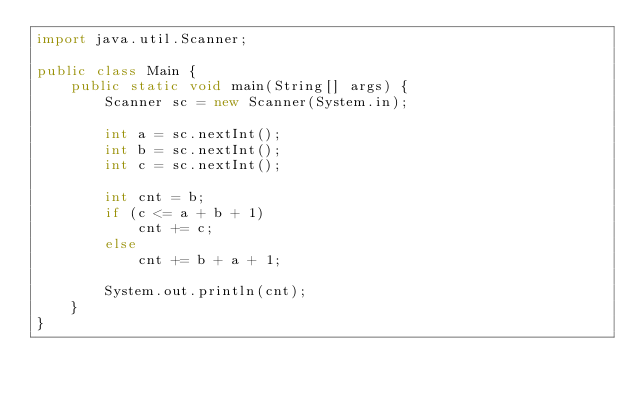Convert code to text. <code><loc_0><loc_0><loc_500><loc_500><_Java_>import java.util.Scanner;

public class Main {
    public static void main(String[] args) {
        Scanner sc = new Scanner(System.in);

        int a = sc.nextInt();
        int b = sc.nextInt();
        int c = sc.nextInt();

        int cnt = b;
        if (c <= a + b + 1)
            cnt += c;
        else
            cnt += b + a + 1;
        
        System.out.println(cnt);
    }
}
</code> 